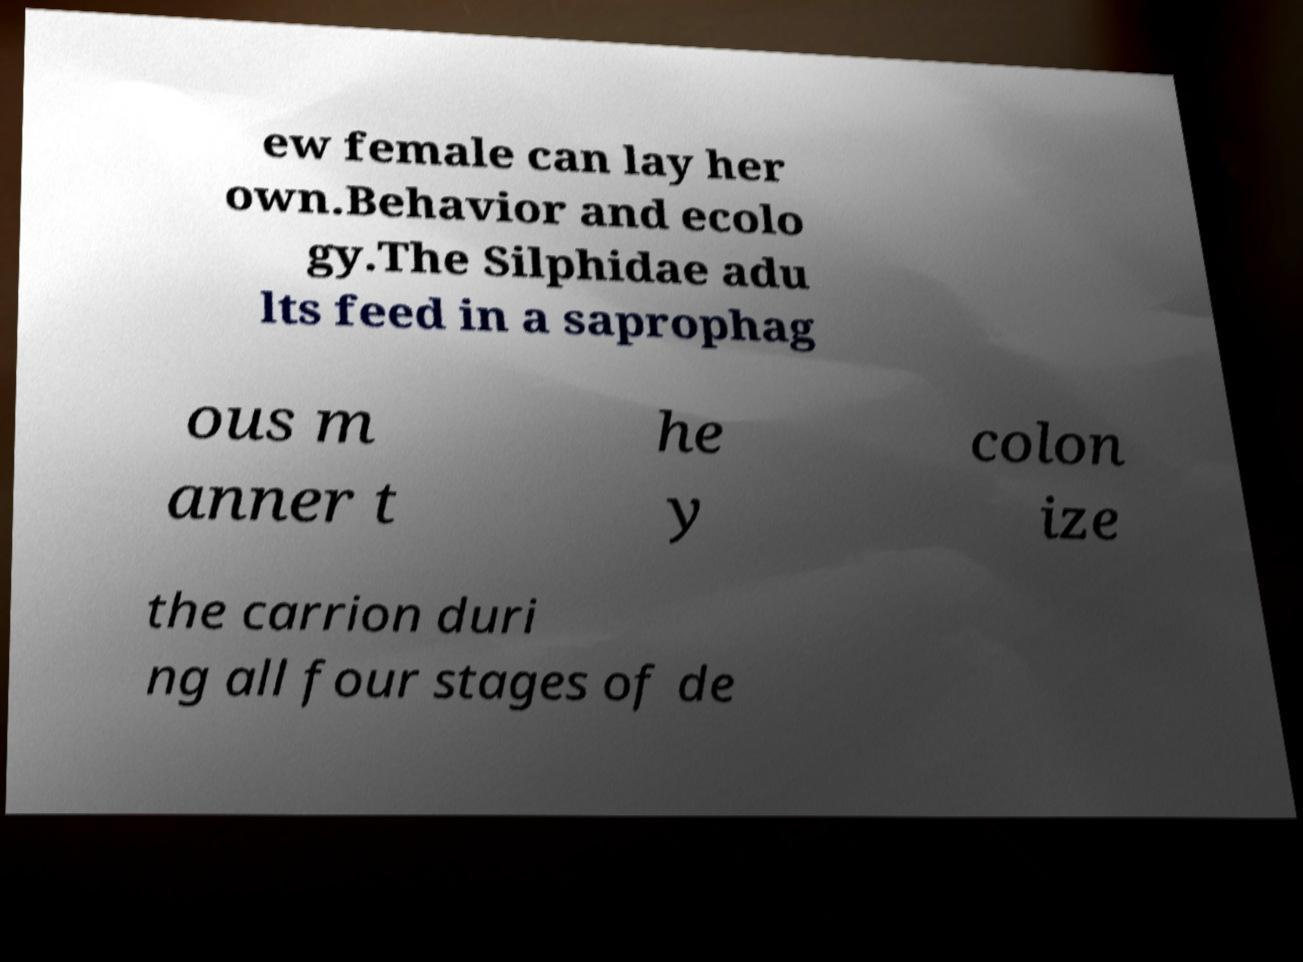For documentation purposes, I need the text within this image transcribed. Could you provide that? ew female can lay her own.Behavior and ecolo gy.The Silphidae adu lts feed in a saprophag ous m anner t he y colon ize the carrion duri ng all four stages of de 